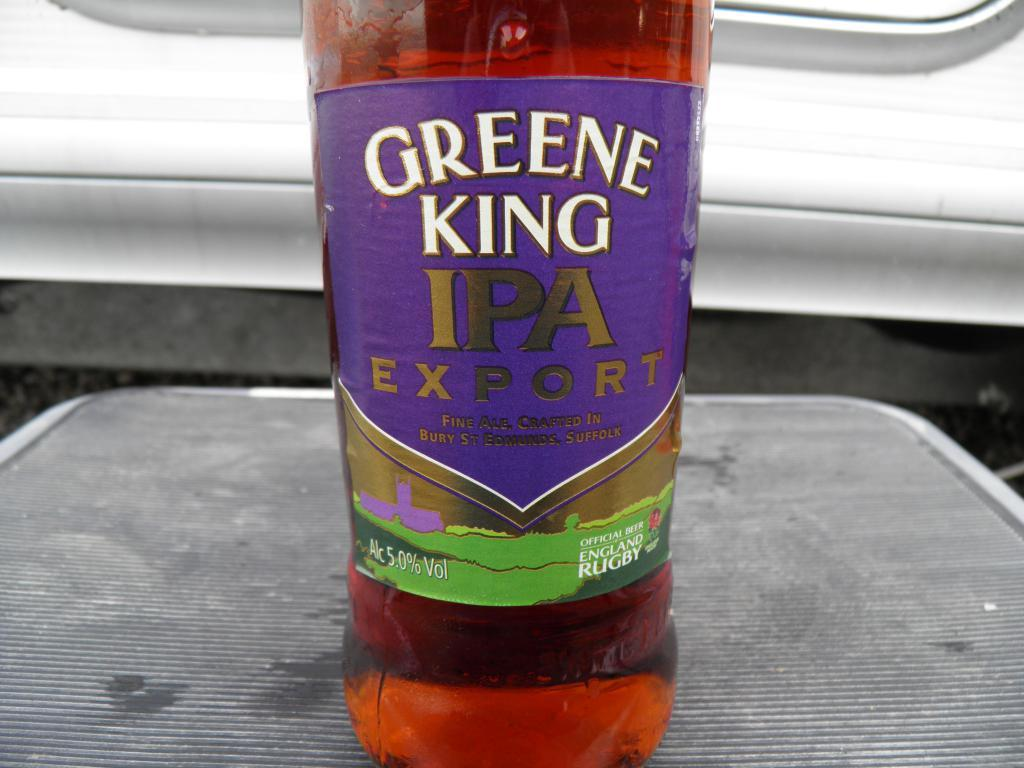Provide a one-sentence caption for the provided image. A red bottle with a purple label that reads Greene King IPA Export. 